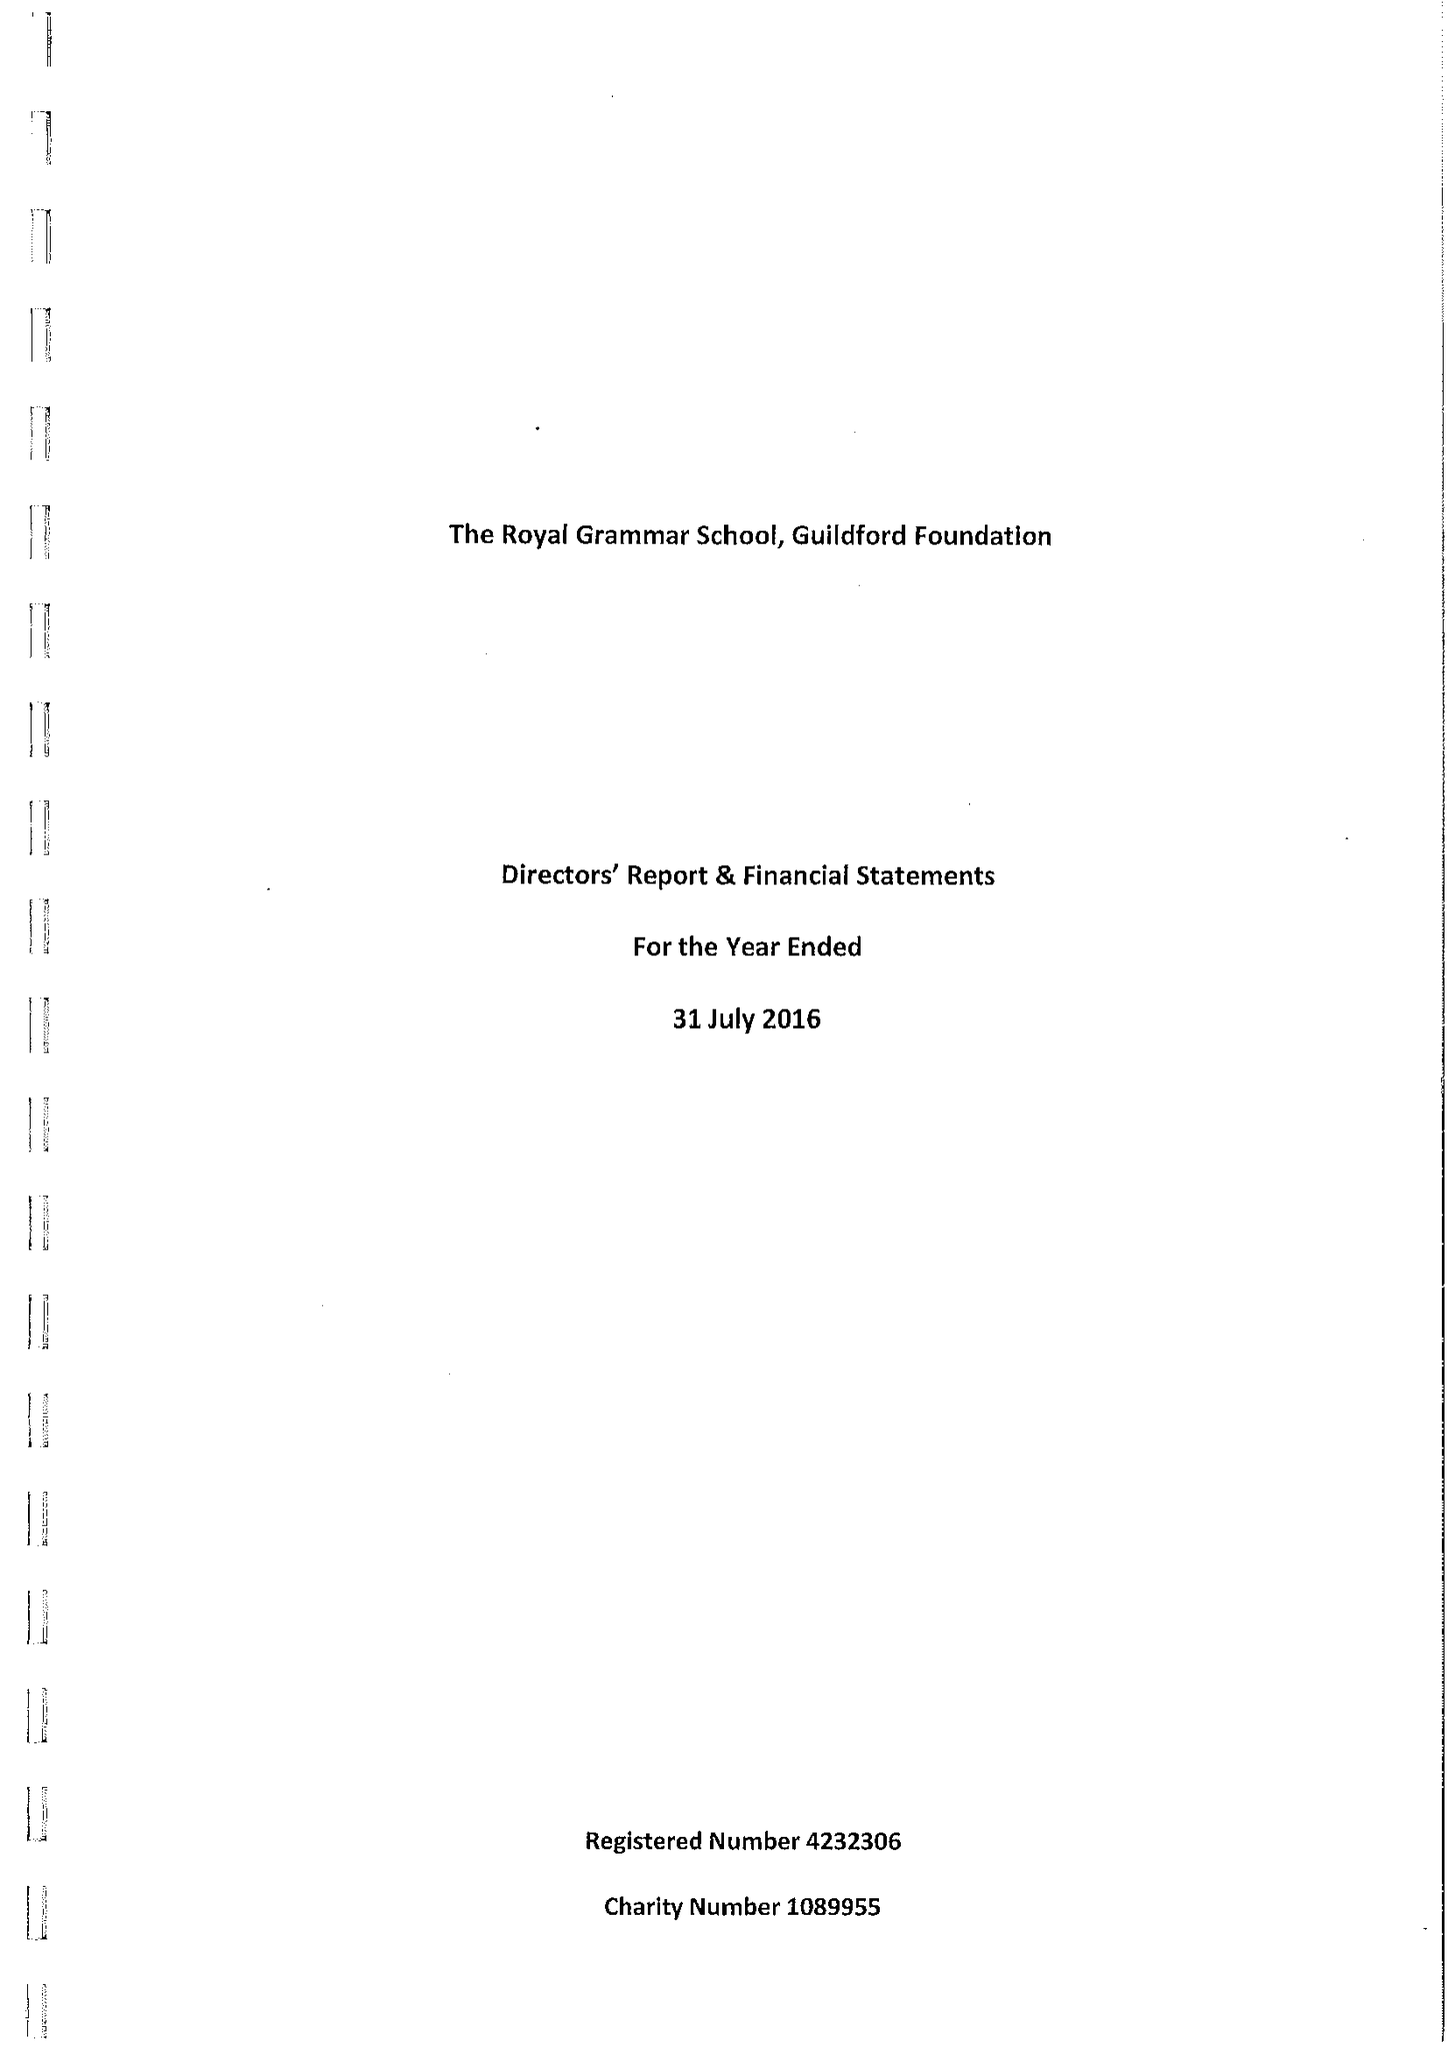What is the value for the report_date?
Answer the question using a single word or phrase. 2016-07-31 